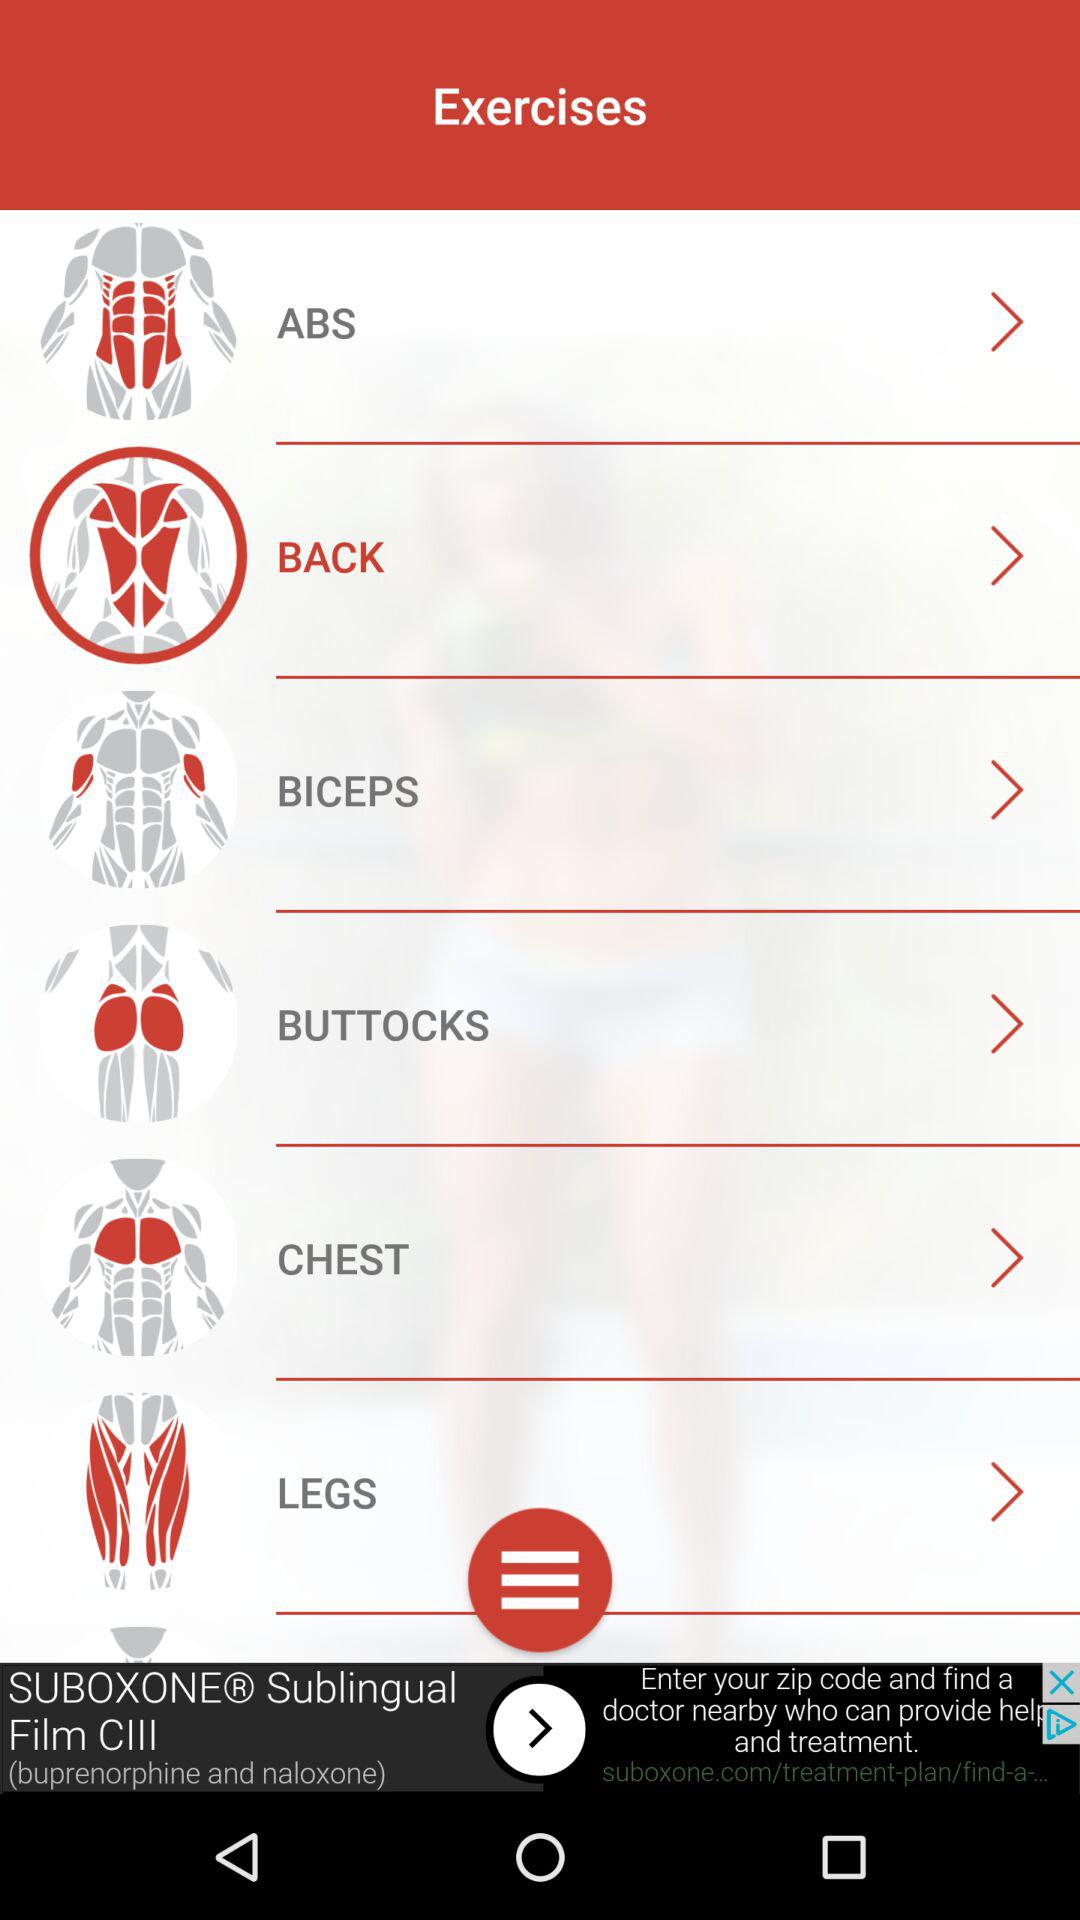What is the selected exercise? The selected exercise is back. 